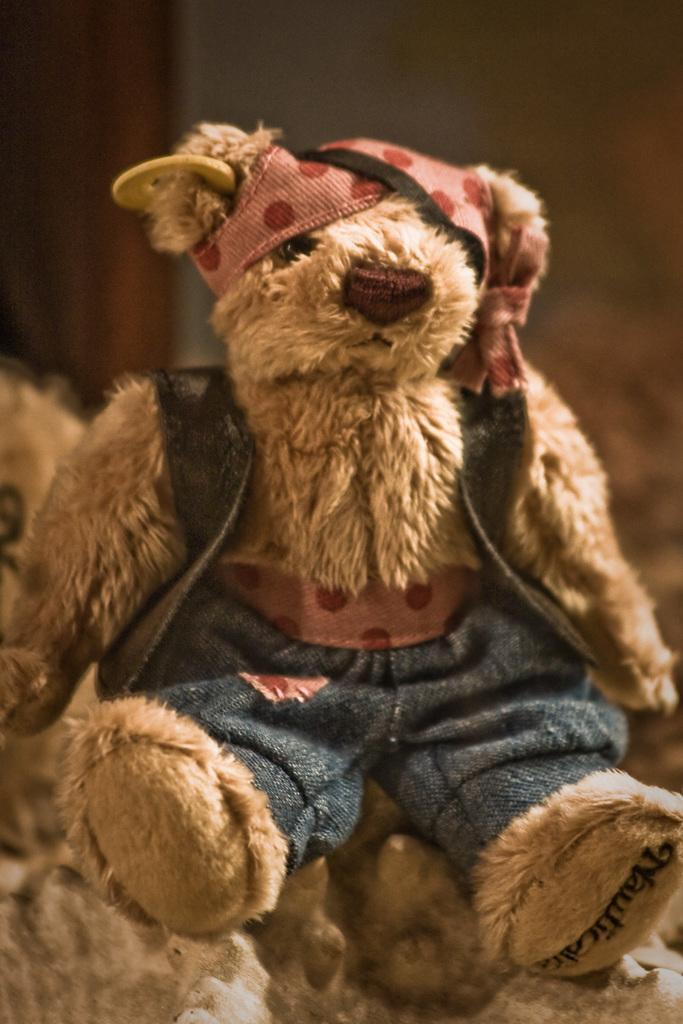Describe this image in one or two sentences. In this image I can see a teddy bear in brown color. 